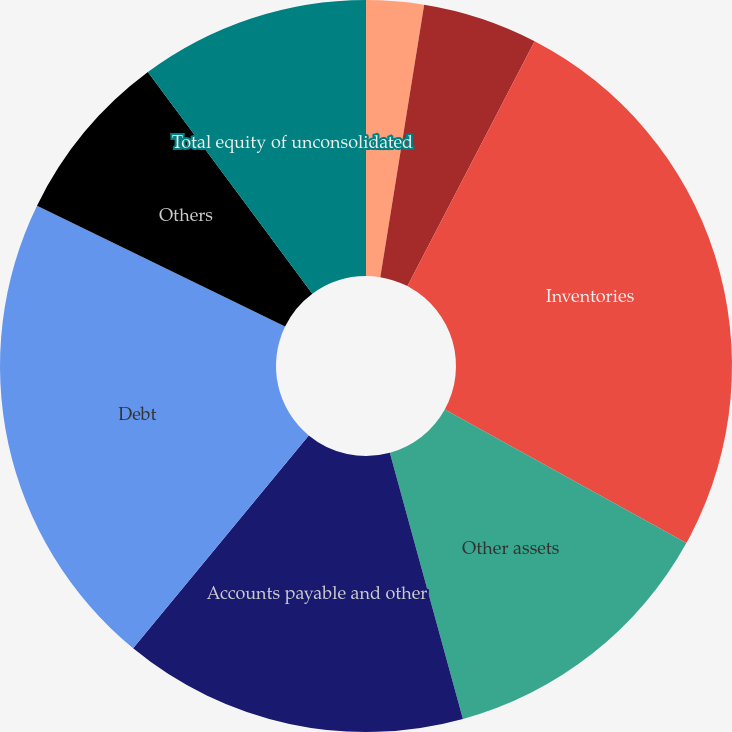Convert chart to OTSL. <chart><loc_0><loc_0><loc_500><loc_500><pie_chart><fcel>Balance Sheets<fcel>Cash and cash equivalents<fcel>Inventories<fcel>Other assets<fcel>Accounts payable and other<fcel>Debt<fcel>Others<fcel>Total equity of unconsolidated<fcel>The Company's interest in<nl><fcel>2.54%<fcel>5.08%<fcel>25.41%<fcel>12.7%<fcel>15.24%<fcel>21.24%<fcel>7.62%<fcel>10.16%<fcel>0.0%<nl></chart> 